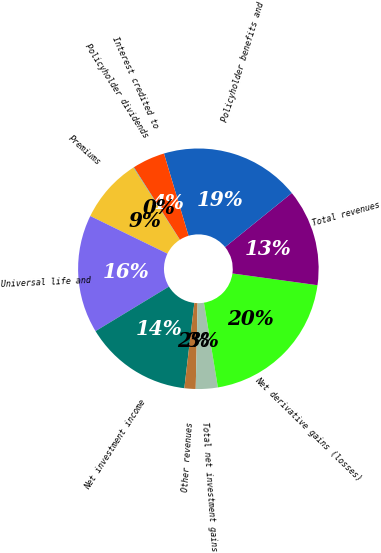<chart> <loc_0><loc_0><loc_500><loc_500><pie_chart><fcel>Premiums<fcel>Universal life and<fcel>Net investment income<fcel>Other revenues<fcel>Total net investment gains<fcel>Net derivative gains (losses)<fcel>Total revenues<fcel>Policyholder benefits and<fcel>Interest credited to<fcel>Policyholder dividends<nl><fcel>8.7%<fcel>15.9%<fcel>14.46%<fcel>1.51%<fcel>2.95%<fcel>20.22%<fcel>13.02%<fcel>18.78%<fcel>4.39%<fcel>0.07%<nl></chart> 